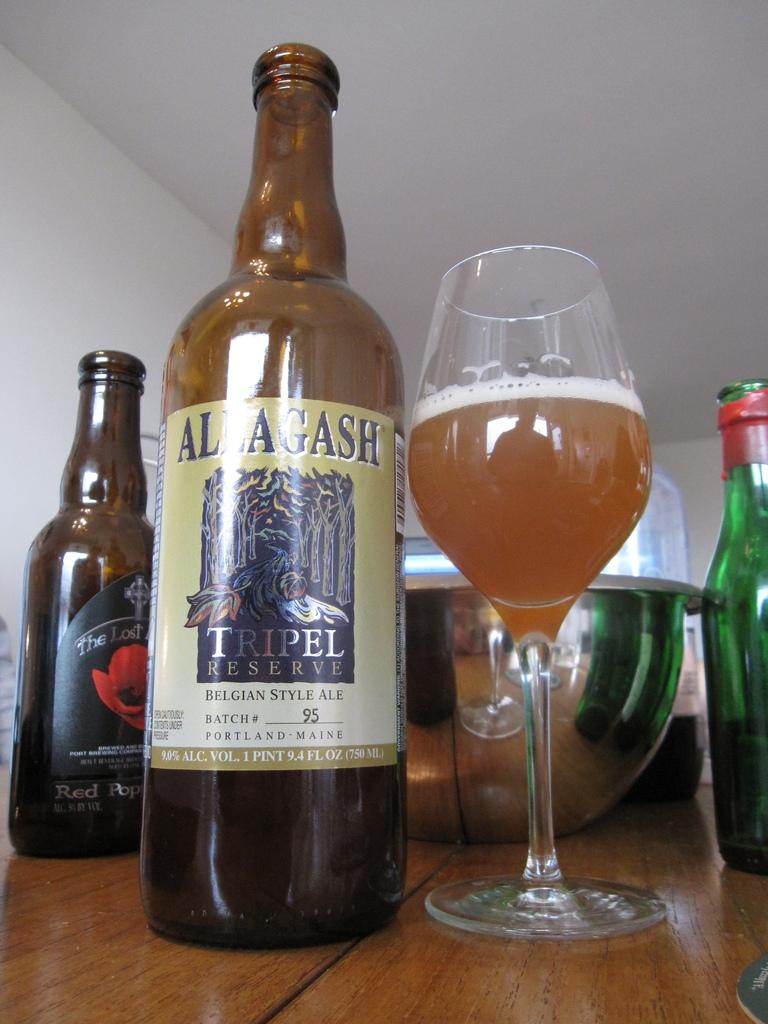Provide a one-sentence caption for the provided image. A bottle of Allagash Tripel Reserve next to a wine glass. 